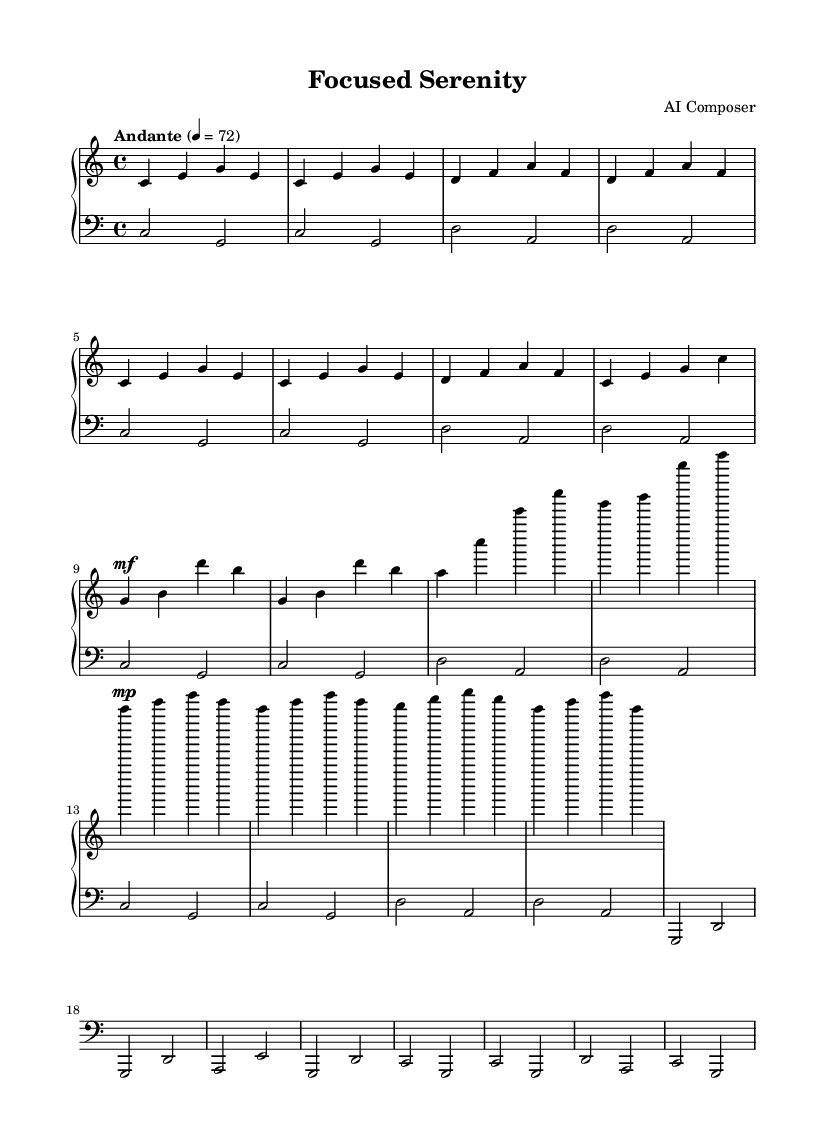What is the key signature of this music? The key signature is C major, which has no sharps or flats.
Answer: C major What is the time signature used in this composition? The time signature shown at the beginning of the staff is 4/4, indicating four beats in each measure.
Answer: 4/4 What is the tempo marking for this piece? The tempo marking above the staff indicates "Andante" with a metronome marking of 72 beats per minute.
Answer: Andante 4 = 72 How many times is the A section repeated? The A section is marked to be repeated two times, evident from the repeat signs.
Answer: 2 What is the dynamic marking at the beginning of section B? The dynamic marking before section B indicates "mf," which stands for mezzo-forte, meaning moderately loud.
Answer: mf Does the left hand play in the treble or bass clef? The left hand is notated in bass clef, which is indicated at the beginning of the left-hand staff.
Answer: Bass clef What is the last note played in the piece? The last note in the sheet music is a G note, which occurs at the conclusion of section A''.
Answer: G 